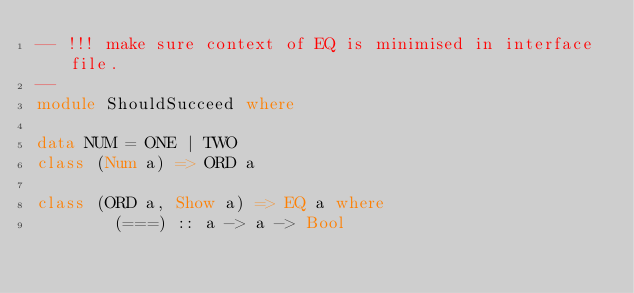Convert code to text. <code><loc_0><loc_0><loc_500><loc_500><_Haskell_>-- !!! make sure context of EQ is minimised in interface file.
--
module ShouldSucceed where

data NUM = ONE | TWO
class (Num a) => ORD a

class (ORD a, Show a) => EQ a where
        (===) :: a -> a -> Bool
</code> 